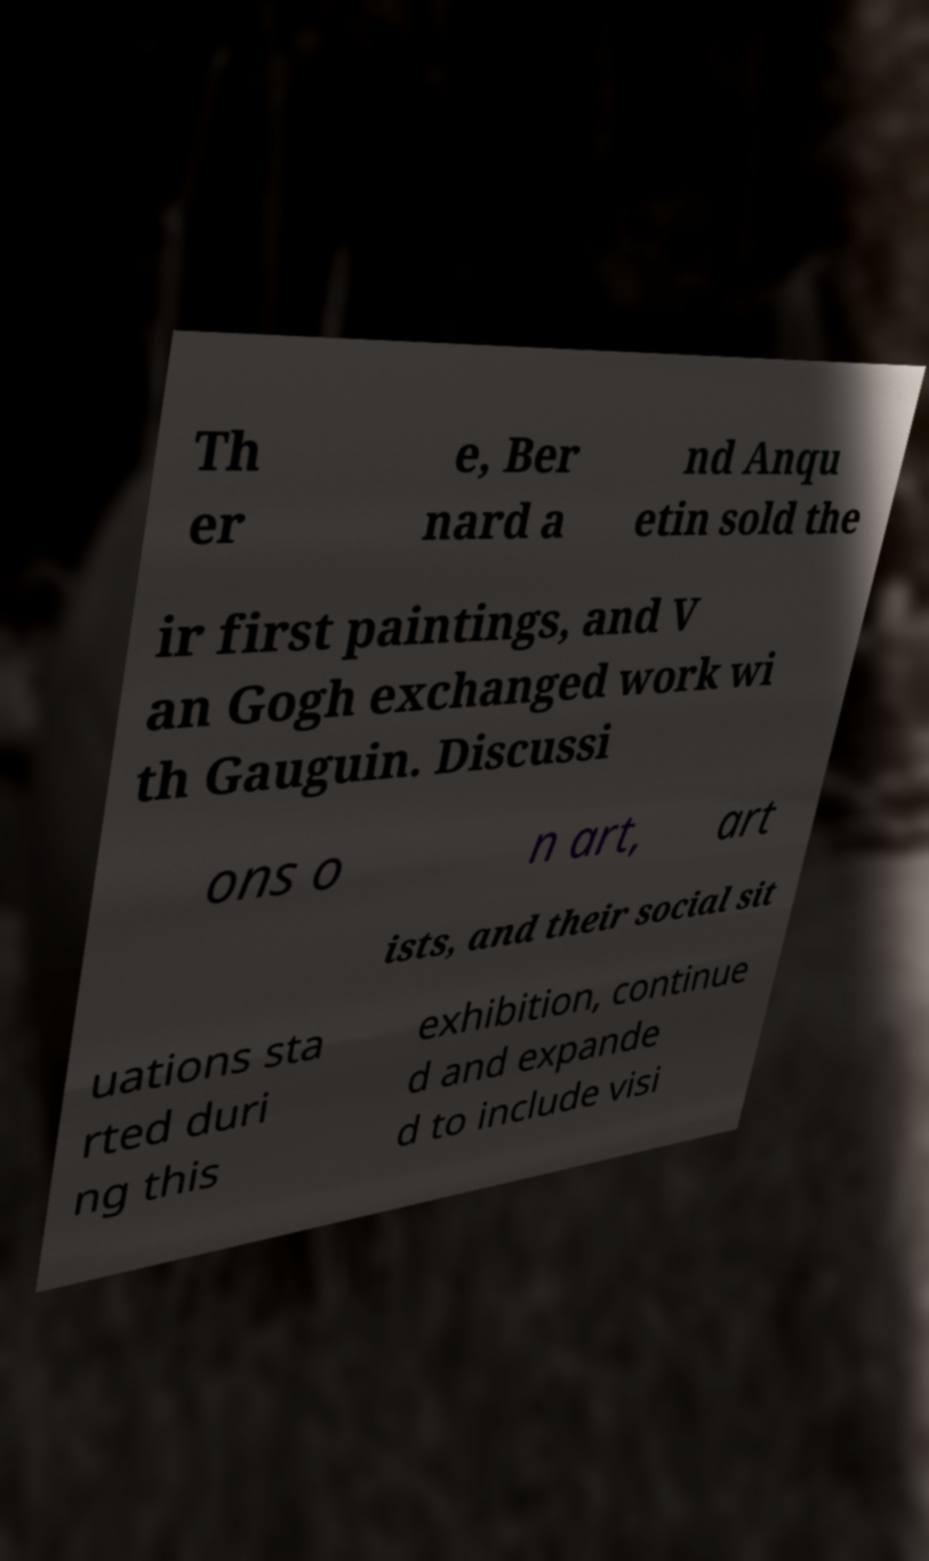Could you assist in decoding the text presented in this image and type it out clearly? Th er e, Ber nard a nd Anqu etin sold the ir first paintings, and V an Gogh exchanged work wi th Gauguin. Discussi ons o n art, art ists, and their social sit uations sta rted duri ng this exhibition, continue d and expande d to include visi 